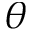<formula> <loc_0><loc_0><loc_500><loc_500>\theta</formula> 